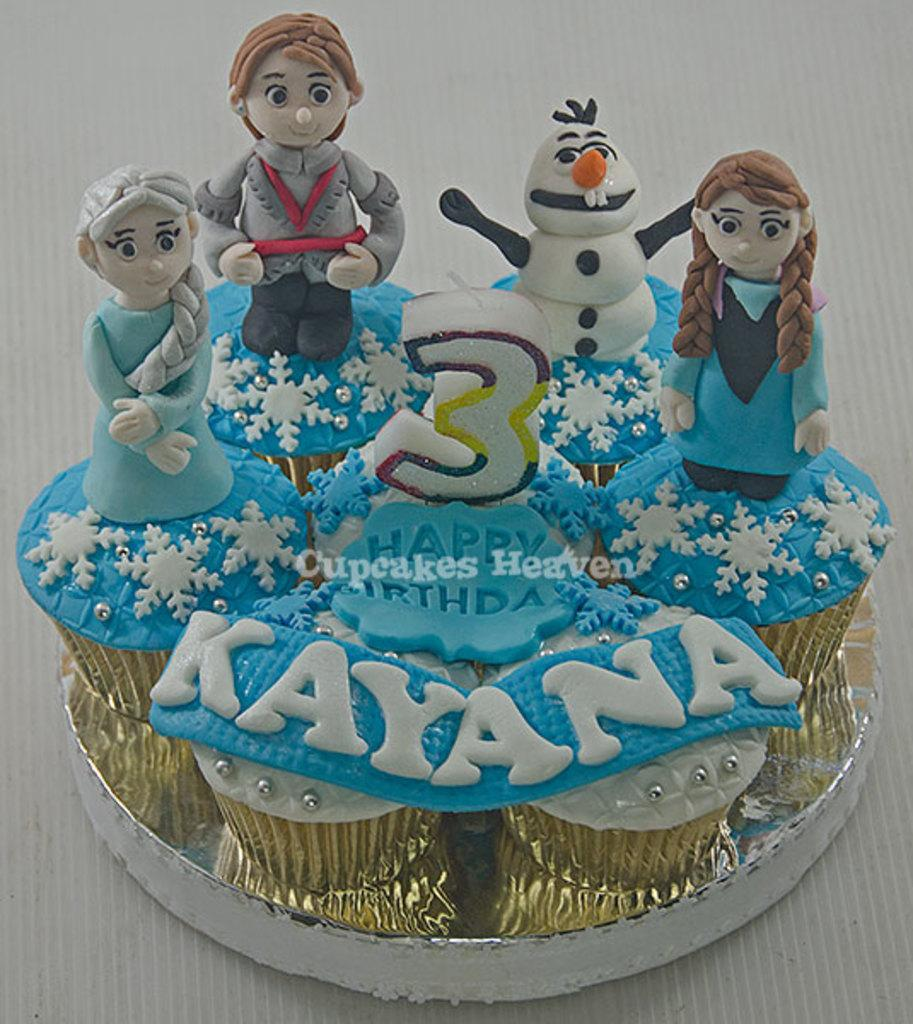What is the main subject of the image? There is a cake in the image. Where is the cake located? The cake is placed on a table. What type of thrill can be experienced by the cake in the image? The cake does not experience any thrill in the image, as it is an inanimate object. 